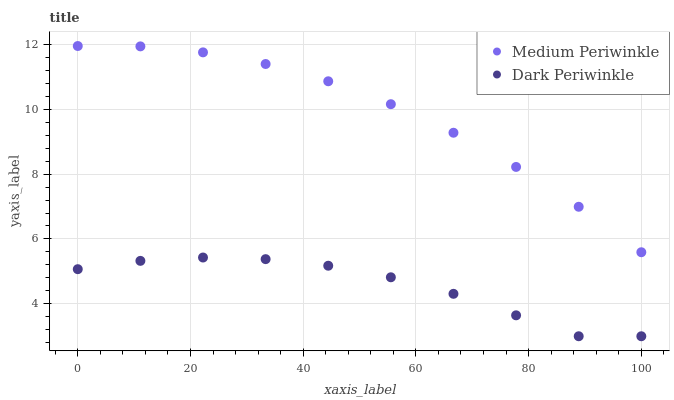Does Dark Periwinkle have the minimum area under the curve?
Answer yes or no. Yes. Does Medium Periwinkle have the maximum area under the curve?
Answer yes or no. Yes. Does Dark Periwinkle have the maximum area under the curve?
Answer yes or no. No. Is Medium Periwinkle the smoothest?
Answer yes or no. Yes. Is Dark Periwinkle the roughest?
Answer yes or no. Yes. Is Dark Periwinkle the smoothest?
Answer yes or no. No. Does Dark Periwinkle have the lowest value?
Answer yes or no. Yes. Does Medium Periwinkle have the highest value?
Answer yes or no. Yes. Does Dark Periwinkle have the highest value?
Answer yes or no. No. Is Dark Periwinkle less than Medium Periwinkle?
Answer yes or no. Yes. Is Medium Periwinkle greater than Dark Periwinkle?
Answer yes or no. Yes. Does Dark Periwinkle intersect Medium Periwinkle?
Answer yes or no. No. 